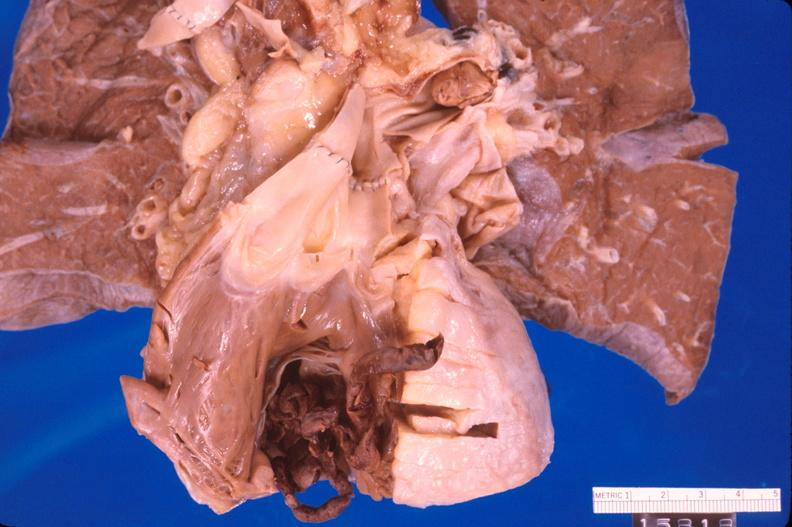does intraductal papillomatosis with apocrine metaplasia show thromboembolus from leg veins in right ventricle?
Answer the question using a single word or phrase. No 